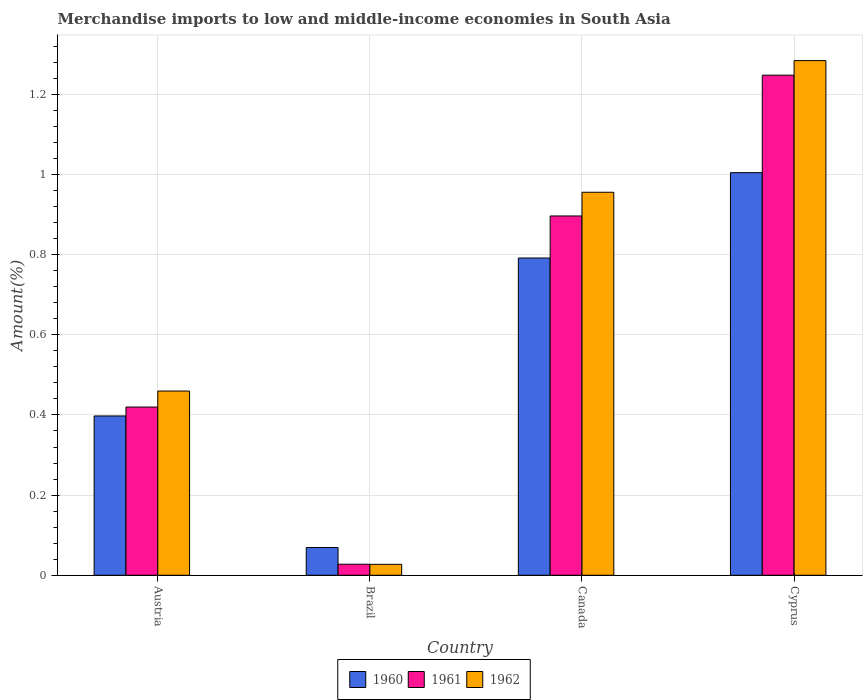How many different coloured bars are there?
Your answer should be compact. 3. Are the number of bars per tick equal to the number of legend labels?
Give a very brief answer. Yes. Are the number of bars on each tick of the X-axis equal?
Your answer should be compact. Yes. How many bars are there on the 2nd tick from the right?
Your answer should be very brief. 3. What is the label of the 3rd group of bars from the left?
Give a very brief answer. Canada. What is the percentage of amount earned from merchandise imports in 1962 in Brazil?
Offer a very short reply. 0.03. Across all countries, what is the maximum percentage of amount earned from merchandise imports in 1962?
Make the answer very short. 1.28. Across all countries, what is the minimum percentage of amount earned from merchandise imports in 1961?
Make the answer very short. 0.03. In which country was the percentage of amount earned from merchandise imports in 1960 maximum?
Provide a short and direct response. Cyprus. In which country was the percentage of amount earned from merchandise imports in 1961 minimum?
Your answer should be very brief. Brazil. What is the total percentage of amount earned from merchandise imports in 1960 in the graph?
Your answer should be very brief. 2.26. What is the difference between the percentage of amount earned from merchandise imports in 1961 in Austria and that in Brazil?
Give a very brief answer. 0.39. What is the difference between the percentage of amount earned from merchandise imports in 1961 in Austria and the percentage of amount earned from merchandise imports in 1962 in Brazil?
Your answer should be compact. 0.39. What is the average percentage of amount earned from merchandise imports in 1960 per country?
Make the answer very short. 0.57. What is the difference between the percentage of amount earned from merchandise imports of/in 1961 and percentage of amount earned from merchandise imports of/in 1962 in Cyprus?
Ensure brevity in your answer.  -0.04. What is the ratio of the percentage of amount earned from merchandise imports in 1962 in Austria to that in Canada?
Your response must be concise. 0.48. Is the difference between the percentage of amount earned from merchandise imports in 1961 in Austria and Cyprus greater than the difference between the percentage of amount earned from merchandise imports in 1962 in Austria and Cyprus?
Your answer should be compact. No. What is the difference between the highest and the second highest percentage of amount earned from merchandise imports in 1961?
Provide a short and direct response. -0.35. What is the difference between the highest and the lowest percentage of amount earned from merchandise imports in 1961?
Provide a succinct answer. 1.22. In how many countries, is the percentage of amount earned from merchandise imports in 1962 greater than the average percentage of amount earned from merchandise imports in 1962 taken over all countries?
Offer a terse response. 2. What does the 3rd bar from the right in Brazil represents?
Give a very brief answer. 1960. How many bars are there?
Give a very brief answer. 12. How many countries are there in the graph?
Give a very brief answer. 4. Are the values on the major ticks of Y-axis written in scientific E-notation?
Provide a succinct answer. No. Does the graph contain grids?
Offer a very short reply. Yes. How are the legend labels stacked?
Give a very brief answer. Horizontal. What is the title of the graph?
Your answer should be very brief. Merchandise imports to low and middle-income economies in South Asia. What is the label or title of the X-axis?
Your answer should be very brief. Country. What is the label or title of the Y-axis?
Your response must be concise. Amount(%). What is the Amount(%) of 1960 in Austria?
Offer a terse response. 0.4. What is the Amount(%) of 1961 in Austria?
Your answer should be very brief. 0.42. What is the Amount(%) of 1962 in Austria?
Your response must be concise. 0.46. What is the Amount(%) in 1960 in Brazil?
Your answer should be compact. 0.07. What is the Amount(%) in 1961 in Brazil?
Your response must be concise. 0.03. What is the Amount(%) of 1962 in Brazil?
Your answer should be compact. 0.03. What is the Amount(%) of 1960 in Canada?
Provide a succinct answer. 0.79. What is the Amount(%) in 1961 in Canada?
Your answer should be compact. 0.9. What is the Amount(%) in 1962 in Canada?
Give a very brief answer. 0.96. What is the Amount(%) of 1960 in Cyprus?
Provide a succinct answer. 1. What is the Amount(%) of 1961 in Cyprus?
Offer a terse response. 1.25. What is the Amount(%) in 1962 in Cyprus?
Keep it short and to the point. 1.28. Across all countries, what is the maximum Amount(%) of 1960?
Offer a terse response. 1. Across all countries, what is the maximum Amount(%) of 1961?
Your answer should be very brief. 1.25. Across all countries, what is the maximum Amount(%) of 1962?
Your answer should be very brief. 1.28. Across all countries, what is the minimum Amount(%) of 1960?
Provide a short and direct response. 0.07. Across all countries, what is the minimum Amount(%) of 1961?
Ensure brevity in your answer.  0.03. Across all countries, what is the minimum Amount(%) of 1962?
Give a very brief answer. 0.03. What is the total Amount(%) in 1960 in the graph?
Provide a succinct answer. 2.26. What is the total Amount(%) of 1961 in the graph?
Give a very brief answer. 2.59. What is the total Amount(%) in 1962 in the graph?
Ensure brevity in your answer.  2.73. What is the difference between the Amount(%) in 1960 in Austria and that in Brazil?
Make the answer very short. 0.33. What is the difference between the Amount(%) in 1961 in Austria and that in Brazil?
Your answer should be compact. 0.39. What is the difference between the Amount(%) in 1962 in Austria and that in Brazil?
Offer a terse response. 0.43. What is the difference between the Amount(%) in 1960 in Austria and that in Canada?
Provide a succinct answer. -0.39. What is the difference between the Amount(%) in 1961 in Austria and that in Canada?
Your answer should be very brief. -0.48. What is the difference between the Amount(%) in 1962 in Austria and that in Canada?
Make the answer very short. -0.5. What is the difference between the Amount(%) in 1960 in Austria and that in Cyprus?
Ensure brevity in your answer.  -0.61. What is the difference between the Amount(%) in 1961 in Austria and that in Cyprus?
Your response must be concise. -0.83. What is the difference between the Amount(%) in 1962 in Austria and that in Cyprus?
Provide a succinct answer. -0.82. What is the difference between the Amount(%) of 1960 in Brazil and that in Canada?
Your answer should be very brief. -0.72. What is the difference between the Amount(%) of 1961 in Brazil and that in Canada?
Your answer should be very brief. -0.87. What is the difference between the Amount(%) in 1962 in Brazil and that in Canada?
Your response must be concise. -0.93. What is the difference between the Amount(%) of 1960 in Brazil and that in Cyprus?
Your answer should be very brief. -0.94. What is the difference between the Amount(%) of 1961 in Brazil and that in Cyprus?
Provide a succinct answer. -1.22. What is the difference between the Amount(%) in 1962 in Brazil and that in Cyprus?
Offer a terse response. -1.26. What is the difference between the Amount(%) in 1960 in Canada and that in Cyprus?
Your answer should be very brief. -0.21. What is the difference between the Amount(%) of 1961 in Canada and that in Cyprus?
Your answer should be compact. -0.35. What is the difference between the Amount(%) of 1962 in Canada and that in Cyprus?
Your answer should be very brief. -0.33. What is the difference between the Amount(%) in 1960 in Austria and the Amount(%) in 1961 in Brazil?
Your answer should be very brief. 0.37. What is the difference between the Amount(%) of 1960 in Austria and the Amount(%) of 1962 in Brazil?
Provide a short and direct response. 0.37. What is the difference between the Amount(%) in 1961 in Austria and the Amount(%) in 1962 in Brazil?
Offer a very short reply. 0.39. What is the difference between the Amount(%) in 1960 in Austria and the Amount(%) in 1961 in Canada?
Your response must be concise. -0.5. What is the difference between the Amount(%) in 1960 in Austria and the Amount(%) in 1962 in Canada?
Your response must be concise. -0.56. What is the difference between the Amount(%) in 1961 in Austria and the Amount(%) in 1962 in Canada?
Ensure brevity in your answer.  -0.54. What is the difference between the Amount(%) of 1960 in Austria and the Amount(%) of 1961 in Cyprus?
Your answer should be compact. -0.85. What is the difference between the Amount(%) in 1960 in Austria and the Amount(%) in 1962 in Cyprus?
Keep it short and to the point. -0.89. What is the difference between the Amount(%) of 1961 in Austria and the Amount(%) of 1962 in Cyprus?
Ensure brevity in your answer.  -0.86. What is the difference between the Amount(%) of 1960 in Brazil and the Amount(%) of 1961 in Canada?
Offer a terse response. -0.83. What is the difference between the Amount(%) of 1960 in Brazil and the Amount(%) of 1962 in Canada?
Offer a terse response. -0.89. What is the difference between the Amount(%) of 1961 in Brazil and the Amount(%) of 1962 in Canada?
Provide a short and direct response. -0.93. What is the difference between the Amount(%) of 1960 in Brazil and the Amount(%) of 1961 in Cyprus?
Give a very brief answer. -1.18. What is the difference between the Amount(%) in 1960 in Brazil and the Amount(%) in 1962 in Cyprus?
Provide a succinct answer. -1.21. What is the difference between the Amount(%) in 1961 in Brazil and the Amount(%) in 1962 in Cyprus?
Provide a succinct answer. -1.26. What is the difference between the Amount(%) in 1960 in Canada and the Amount(%) in 1961 in Cyprus?
Ensure brevity in your answer.  -0.46. What is the difference between the Amount(%) of 1960 in Canada and the Amount(%) of 1962 in Cyprus?
Your answer should be compact. -0.49. What is the difference between the Amount(%) in 1961 in Canada and the Amount(%) in 1962 in Cyprus?
Make the answer very short. -0.39. What is the average Amount(%) of 1960 per country?
Your answer should be very brief. 0.57. What is the average Amount(%) in 1961 per country?
Ensure brevity in your answer.  0.65. What is the average Amount(%) in 1962 per country?
Give a very brief answer. 0.68. What is the difference between the Amount(%) in 1960 and Amount(%) in 1961 in Austria?
Keep it short and to the point. -0.02. What is the difference between the Amount(%) in 1960 and Amount(%) in 1962 in Austria?
Your answer should be compact. -0.06. What is the difference between the Amount(%) of 1961 and Amount(%) of 1962 in Austria?
Keep it short and to the point. -0.04. What is the difference between the Amount(%) of 1960 and Amount(%) of 1961 in Brazil?
Offer a terse response. 0.04. What is the difference between the Amount(%) in 1960 and Amount(%) in 1962 in Brazil?
Offer a terse response. 0.04. What is the difference between the Amount(%) in 1960 and Amount(%) in 1961 in Canada?
Ensure brevity in your answer.  -0.1. What is the difference between the Amount(%) in 1960 and Amount(%) in 1962 in Canada?
Offer a very short reply. -0.16. What is the difference between the Amount(%) of 1961 and Amount(%) of 1962 in Canada?
Your answer should be compact. -0.06. What is the difference between the Amount(%) in 1960 and Amount(%) in 1961 in Cyprus?
Offer a terse response. -0.24. What is the difference between the Amount(%) of 1960 and Amount(%) of 1962 in Cyprus?
Your answer should be very brief. -0.28. What is the difference between the Amount(%) in 1961 and Amount(%) in 1962 in Cyprus?
Provide a short and direct response. -0.04. What is the ratio of the Amount(%) in 1960 in Austria to that in Brazil?
Provide a succinct answer. 5.73. What is the ratio of the Amount(%) of 1961 in Austria to that in Brazil?
Your response must be concise. 15.2. What is the ratio of the Amount(%) in 1962 in Austria to that in Brazil?
Give a very brief answer. 16.83. What is the ratio of the Amount(%) of 1960 in Austria to that in Canada?
Keep it short and to the point. 0.5. What is the ratio of the Amount(%) in 1961 in Austria to that in Canada?
Your answer should be compact. 0.47. What is the ratio of the Amount(%) in 1962 in Austria to that in Canada?
Provide a short and direct response. 0.48. What is the ratio of the Amount(%) in 1960 in Austria to that in Cyprus?
Provide a short and direct response. 0.4. What is the ratio of the Amount(%) in 1961 in Austria to that in Cyprus?
Your answer should be very brief. 0.34. What is the ratio of the Amount(%) of 1962 in Austria to that in Cyprus?
Offer a very short reply. 0.36. What is the ratio of the Amount(%) in 1960 in Brazil to that in Canada?
Ensure brevity in your answer.  0.09. What is the ratio of the Amount(%) of 1961 in Brazil to that in Canada?
Make the answer very short. 0.03. What is the ratio of the Amount(%) in 1962 in Brazil to that in Canada?
Your answer should be very brief. 0.03. What is the ratio of the Amount(%) in 1960 in Brazil to that in Cyprus?
Give a very brief answer. 0.07. What is the ratio of the Amount(%) in 1961 in Brazil to that in Cyprus?
Your response must be concise. 0.02. What is the ratio of the Amount(%) of 1962 in Brazil to that in Cyprus?
Give a very brief answer. 0.02. What is the ratio of the Amount(%) of 1960 in Canada to that in Cyprus?
Offer a terse response. 0.79. What is the ratio of the Amount(%) in 1961 in Canada to that in Cyprus?
Ensure brevity in your answer.  0.72. What is the ratio of the Amount(%) in 1962 in Canada to that in Cyprus?
Make the answer very short. 0.74. What is the difference between the highest and the second highest Amount(%) in 1960?
Make the answer very short. 0.21. What is the difference between the highest and the second highest Amount(%) in 1961?
Your response must be concise. 0.35. What is the difference between the highest and the second highest Amount(%) of 1962?
Your response must be concise. 0.33. What is the difference between the highest and the lowest Amount(%) of 1960?
Your answer should be compact. 0.94. What is the difference between the highest and the lowest Amount(%) in 1961?
Offer a terse response. 1.22. What is the difference between the highest and the lowest Amount(%) in 1962?
Provide a short and direct response. 1.26. 